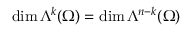Convert formula to latex. <formula><loc_0><loc_0><loc_500><loc_500>\dim \Lambda ^ { k } ( \Omega ) = \dim \Lambda ^ { n - k } ( \Omega )</formula> 